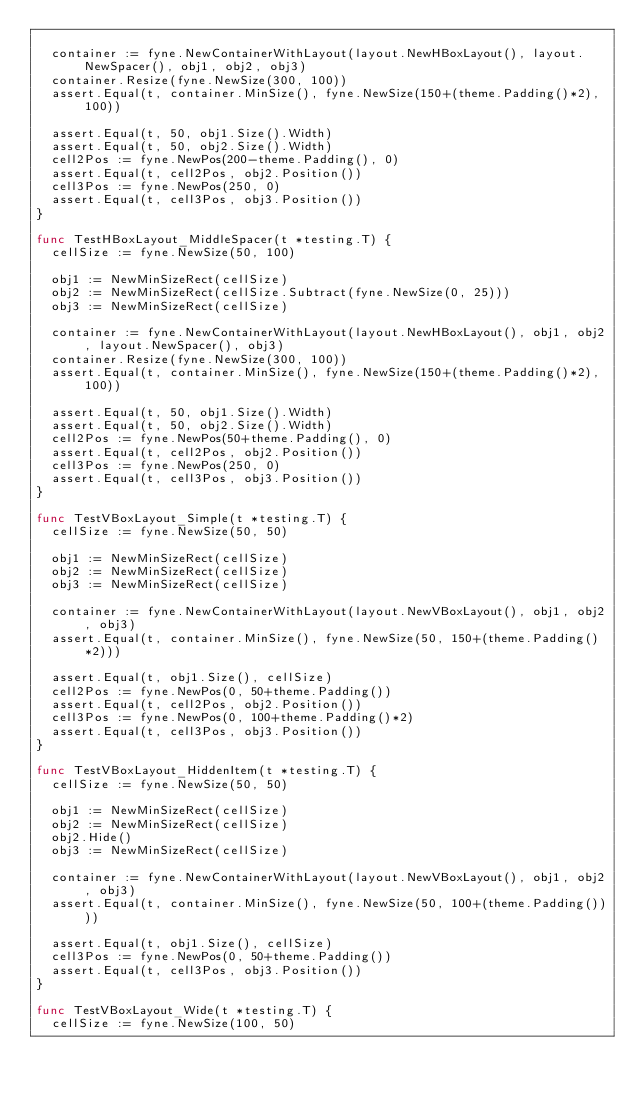Convert code to text. <code><loc_0><loc_0><loc_500><loc_500><_Go_>
	container := fyne.NewContainerWithLayout(layout.NewHBoxLayout(), layout.NewSpacer(), obj1, obj2, obj3)
	container.Resize(fyne.NewSize(300, 100))
	assert.Equal(t, container.MinSize(), fyne.NewSize(150+(theme.Padding()*2), 100))

	assert.Equal(t, 50, obj1.Size().Width)
	assert.Equal(t, 50, obj2.Size().Width)
	cell2Pos := fyne.NewPos(200-theme.Padding(), 0)
	assert.Equal(t, cell2Pos, obj2.Position())
	cell3Pos := fyne.NewPos(250, 0)
	assert.Equal(t, cell3Pos, obj3.Position())
}

func TestHBoxLayout_MiddleSpacer(t *testing.T) {
	cellSize := fyne.NewSize(50, 100)

	obj1 := NewMinSizeRect(cellSize)
	obj2 := NewMinSizeRect(cellSize.Subtract(fyne.NewSize(0, 25)))
	obj3 := NewMinSizeRect(cellSize)

	container := fyne.NewContainerWithLayout(layout.NewHBoxLayout(), obj1, obj2, layout.NewSpacer(), obj3)
	container.Resize(fyne.NewSize(300, 100))
	assert.Equal(t, container.MinSize(), fyne.NewSize(150+(theme.Padding()*2), 100))

	assert.Equal(t, 50, obj1.Size().Width)
	assert.Equal(t, 50, obj2.Size().Width)
	cell2Pos := fyne.NewPos(50+theme.Padding(), 0)
	assert.Equal(t, cell2Pos, obj2.Position())
	cell3Pos := fyne.NewPos(250, 0)
	assert.Equal(t, cell3Pos, obj3.Position())
}

func TestVBoxLayout_Simple(t *testing.T) {
	cellSize := fyne.NewSize(50, 50)

	obj1 := NewMinSizeRect(cellSize)
	obj2 := NewMinSizeRect(cellSize)
	obj3 := NewMinSizeRect(cellSize)

	container := fyne.NewContainerWithLayout(layout.NewVBoxLayout(), obj1, obj2, obj3)
	assert.Equal(t, container.MinSize(), fyne.NewSize(50, 150+(theme.Padding()*2)))

	assert.Equal(t, obj1.Size(), cellSize)
	cell2Pos := fyne.NewPos(0, 50+theme.Padding())
	assert.Equal(t, cell2Pos, obj2.Position())
	cell3Pos := fyne.NewPos(0, 100+theme.Padding()*2)
	assert.Equal(t, cell3Pos, obj3.Position())
}

func TestVBoxLayout_HiddenItem(t *testing.T) {
	cellSize := fyne.NewSize(50, 50)

	obj1 := NewMinSizeRect(cellSize)
	obj2 := NewMinSizeRect(cellSize)
	obj2.Hide()
	obj3 := NewMinSizeRect(cellSize)

	container := fyne.NewContainerWithLayout(layout.NewVBoxLayout(), obj1, obj2, obj3)
	assert.Equal(t, container.MinSize(), fyne.NewSize(50, 100+(theme.Padding())))

	assert.Equal(t, obj1.Size(), cellSize)
	cell3Pos := fyne.NewPos(0, 50+theme.Padding())
	assert.Equal(t, cell3Pos, obj3.Position())
}

func TestVBoxLayout_Wide(t *testing.T) {
	cellSize := fyne.NewSize(100, 50)
</code> 